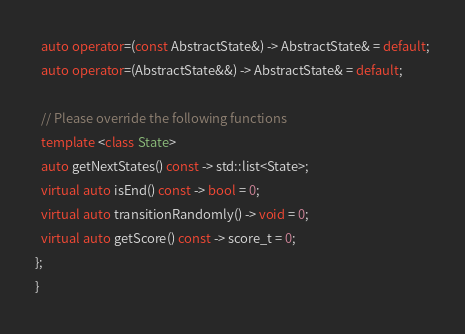Convert code to text. <code><loc_0><loc_0><loc_500><loc_500><_C++_>
  auto operator=(const AbstractState&) -> AbstractState& = default;
  auto operator=(AbstractState&&) -> AbstractState& = default;

  // Please override the following functions
  template <class State>
  auto getNextStates() const -> std::list<State>;
  virtual auto isEnd() const -> bool = 0;
  virtual auto transitionRandomly() -> void = 0;
  virtual auto getScore() const -> score_t = 0;
};
}
</code> 